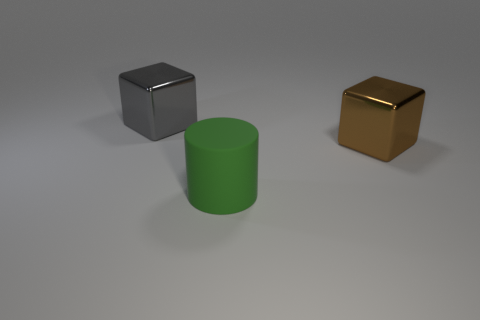Add 3 big matte cubes. How many objects exist? 6 Subtract all cylinders. How many objects are left? 2 Subtract all green objects. Subtract all big brown objects. How many objects are left? 1 Add 2 gray things. How many gray things are left? 3 Add 3 tiny brown metallic blocks. How many tiny brown metallic blocks exist? 3 Subtract 0 red balls. How many objects are left? 3 